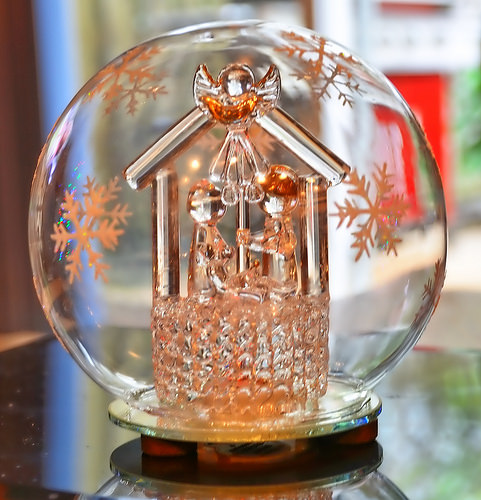<image>
Is the snowflake in the glass? Yes. The snowflake is contained within or inside the glass, showing a containment relationship. 